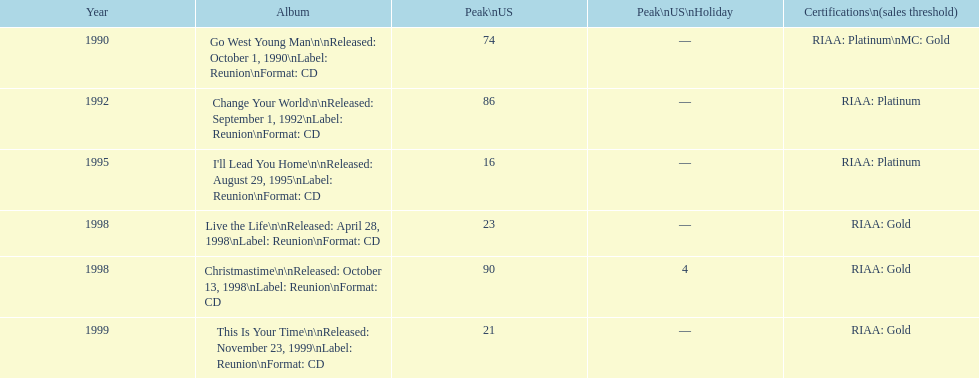Among michael w. smith's albums, which one had the top ranking on the us chart? I'll Lead You Home. 